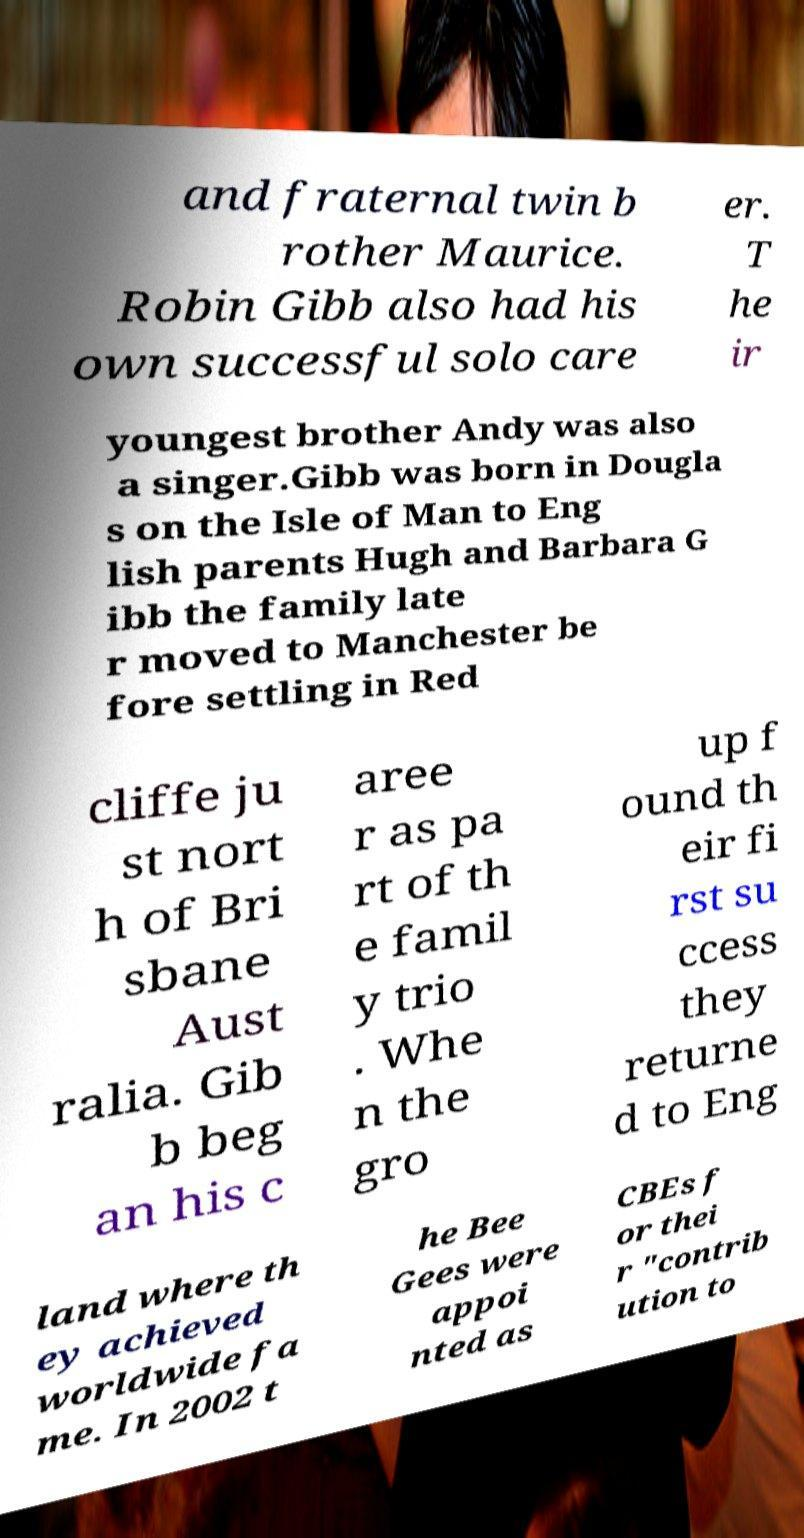What messages or text are displayed in this image? I need them in a readable, typed format. and fraternal twin b rother Maurice. Robin Gibb also had his own successful solo care er. T he ir youngest brother Andy was also a singer.Gibb was born in Dougla s on the Isle of Man to Eng lish parents Hugh and Barbara G ibb the family late r moved to Manchester be fore settling in Red cliffe ju st nort h of Bri sbane Aust ralia. Gib b beg an his c aree r as pa rt of th e famil y trio . Whe n the gro up f ound th eir fi rst su ccess they returne d to Eng land where th ey achieved worldwide fa me. In 2002 t he Bee Gees were appoi nted as CBEs f or thei r "contrib ution to 